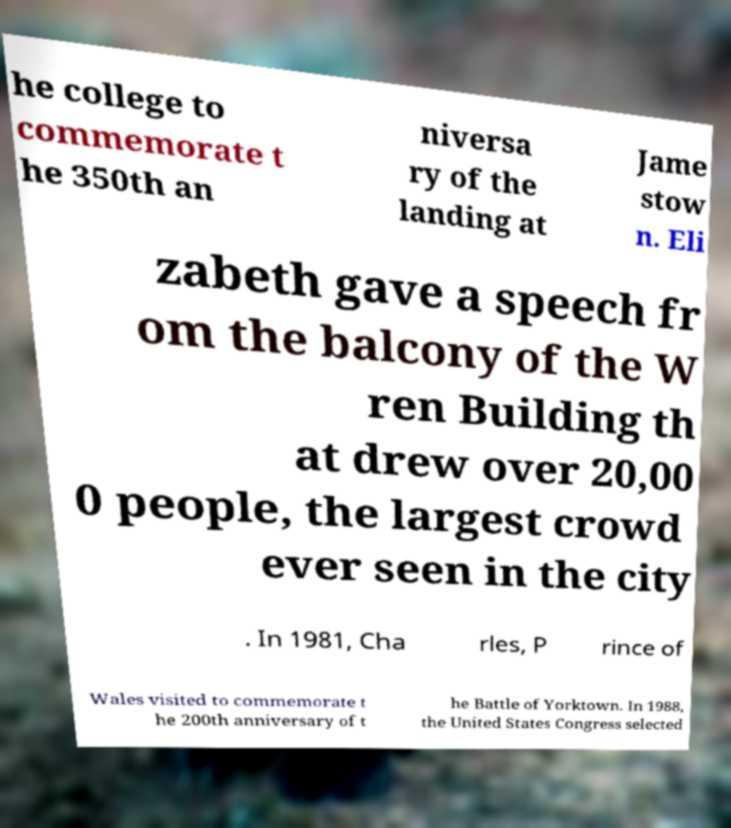What messages or text are displayed in this image? I need them in a readable, typed format. he college to commemorate t he 350th an niversa ry of the landing at Jame stow n. Eli zabeth gave a speech fr om the balcony of the W ren Building th at drew over 20,00 0 people, the largest crowd ever seen in the city . In 1981, Cha rles, P rince of Wales visited to commemorate t he 200th anniversary of t he Battle of Yorktown. In 1988, the United States Congress selected 